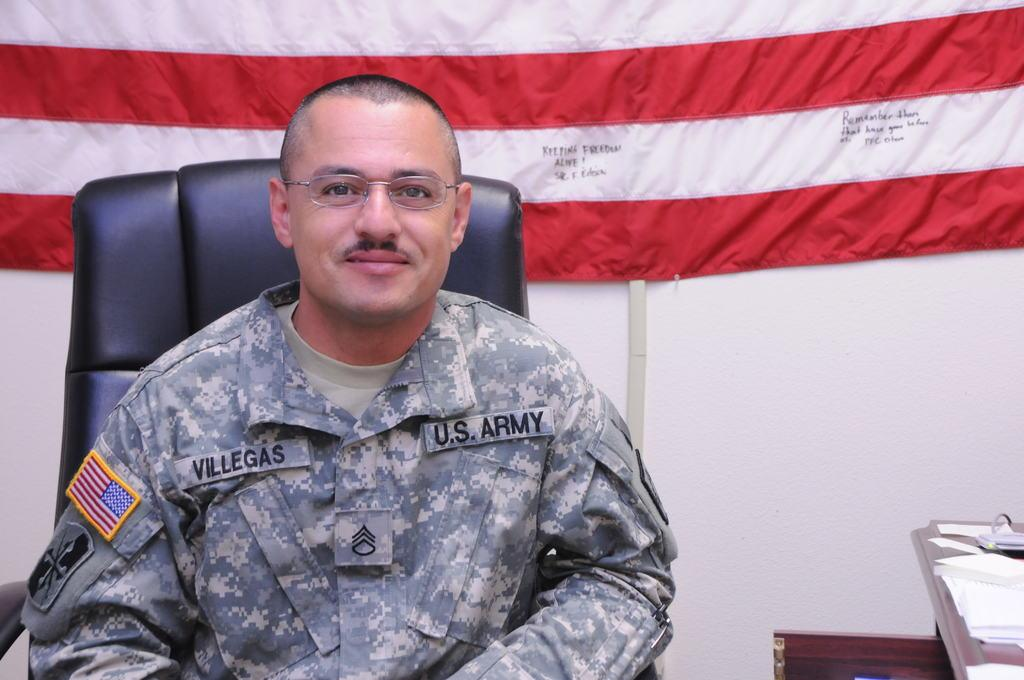What is the person in the image doing? The person is sitting on a chair in the image. What object is present in the image that the person might be using? There is a table in the image that the person might be using. What is on the table in the image? There are papers on the table in the image. What additional detail can be observed in the image? There is a flag visible in the image. What type of wood is the kettle made of in the image? There is no kettle present in the image, so it is not possible to determine what type of wood it might be made of. 